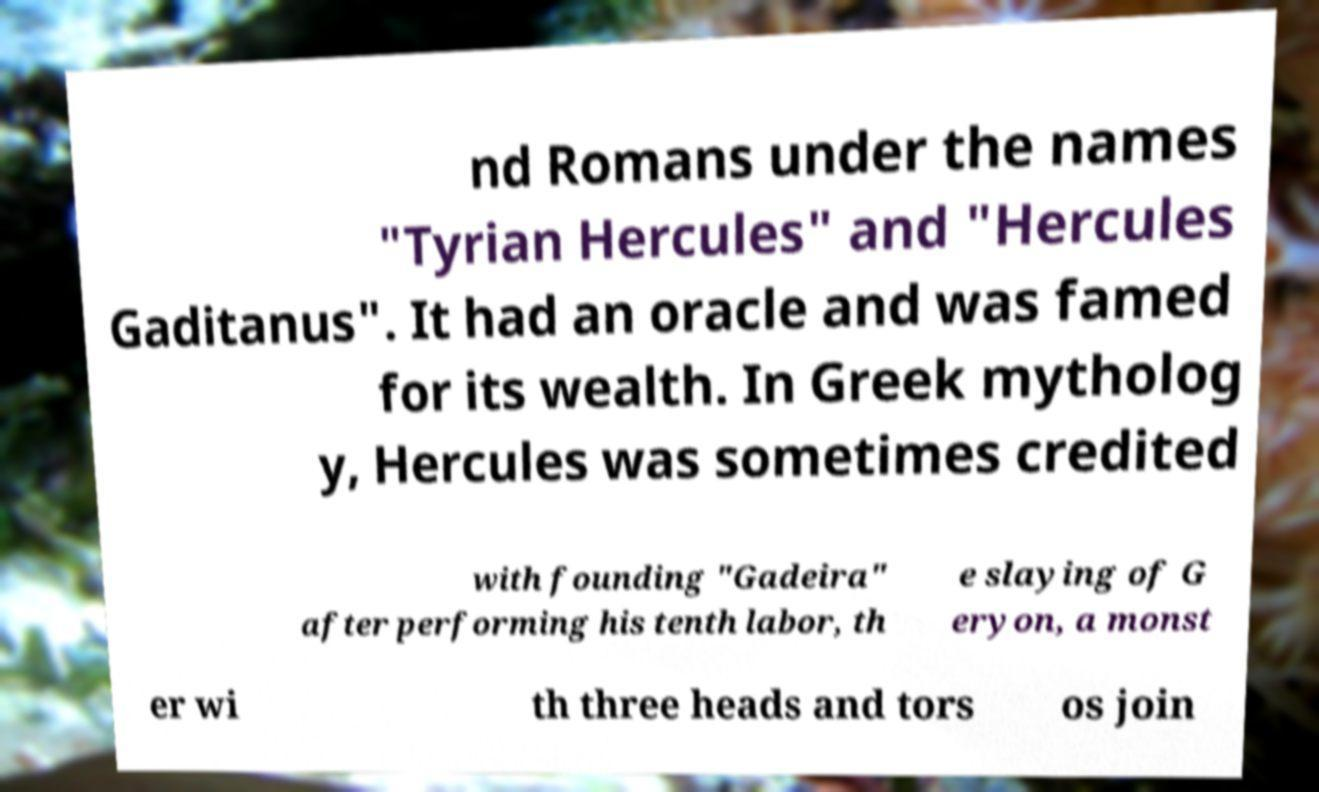There's text embedded in this image that I need extracted. Can you transcribe it verbatim? nd Romans under the names "Tyrian Hercules" and "Hercules Gaditanus". It had an oracle and was famed for its wealth. In Greek mytholog y, Hercules was sometimes credited with founding "Gadeira" after performing his tenth labor, th e slaying of G eryon, a monst er wi th three heads and tors os join 